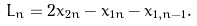Convert formula to latex. <formula><loc_0><loc_0><loc_500><loc_500>L _ { n } = 2 x _ { 2 n } - x _ { 1 n } - x _ { 1 , n - 1 } .</formula> 